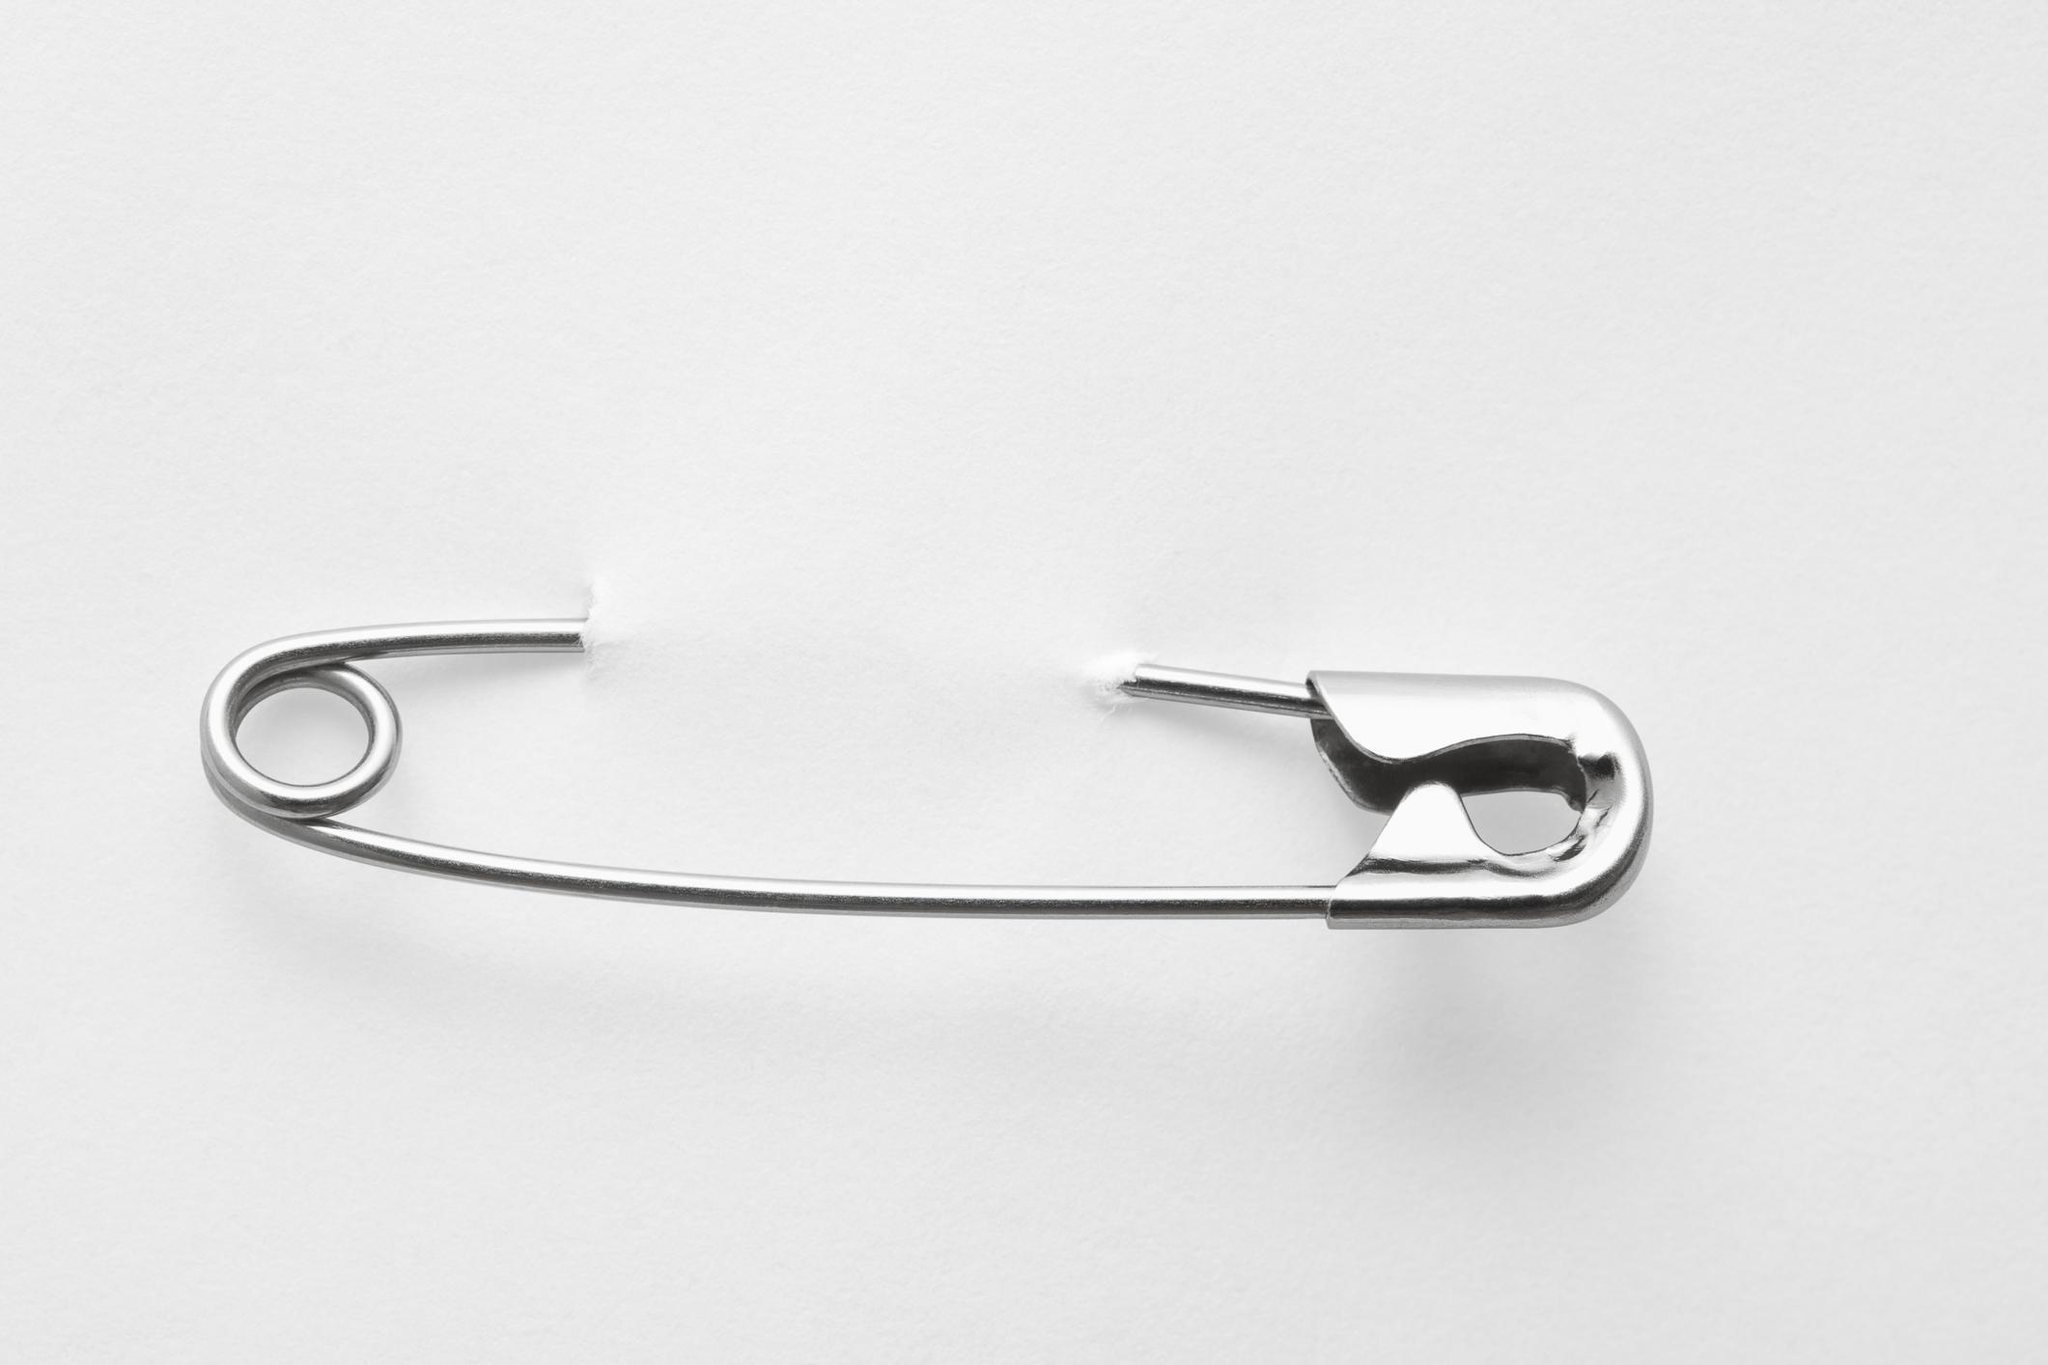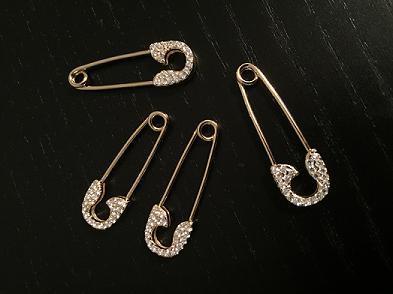The first image is the image on the left, the second image is the image on the right. Examine the images to the left and right. Is the description "An image contains one horizontal silver pin pierced through a solid color material." accurate? Answer yes or no. Yes. 